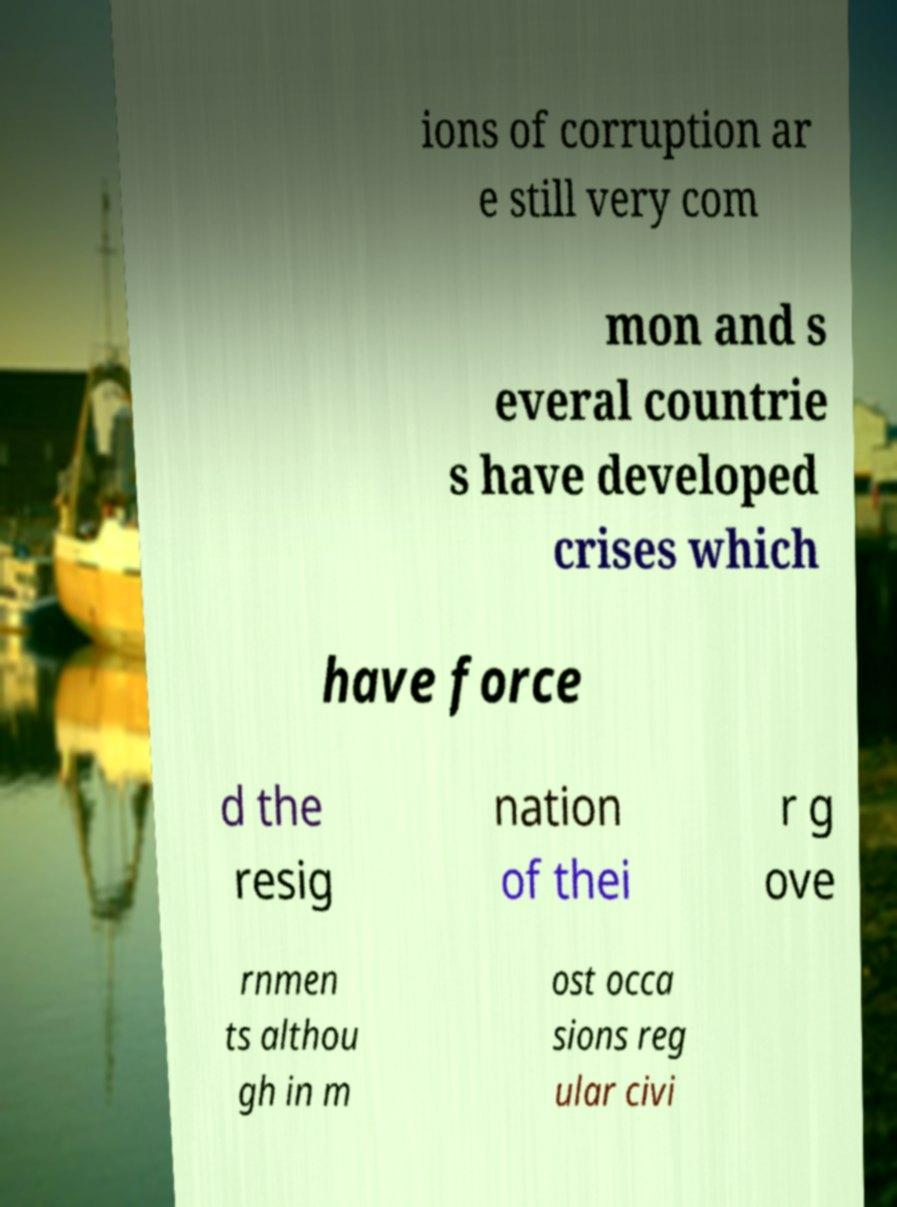I need the written content from this picture converted into text. Can you do that? ions of corruption ar e still very com mon and s everal countrie s have developed crises which have force d the resig nation of thei r g ove rnmen ts althou gh in m ost occa sions reg ular civi 